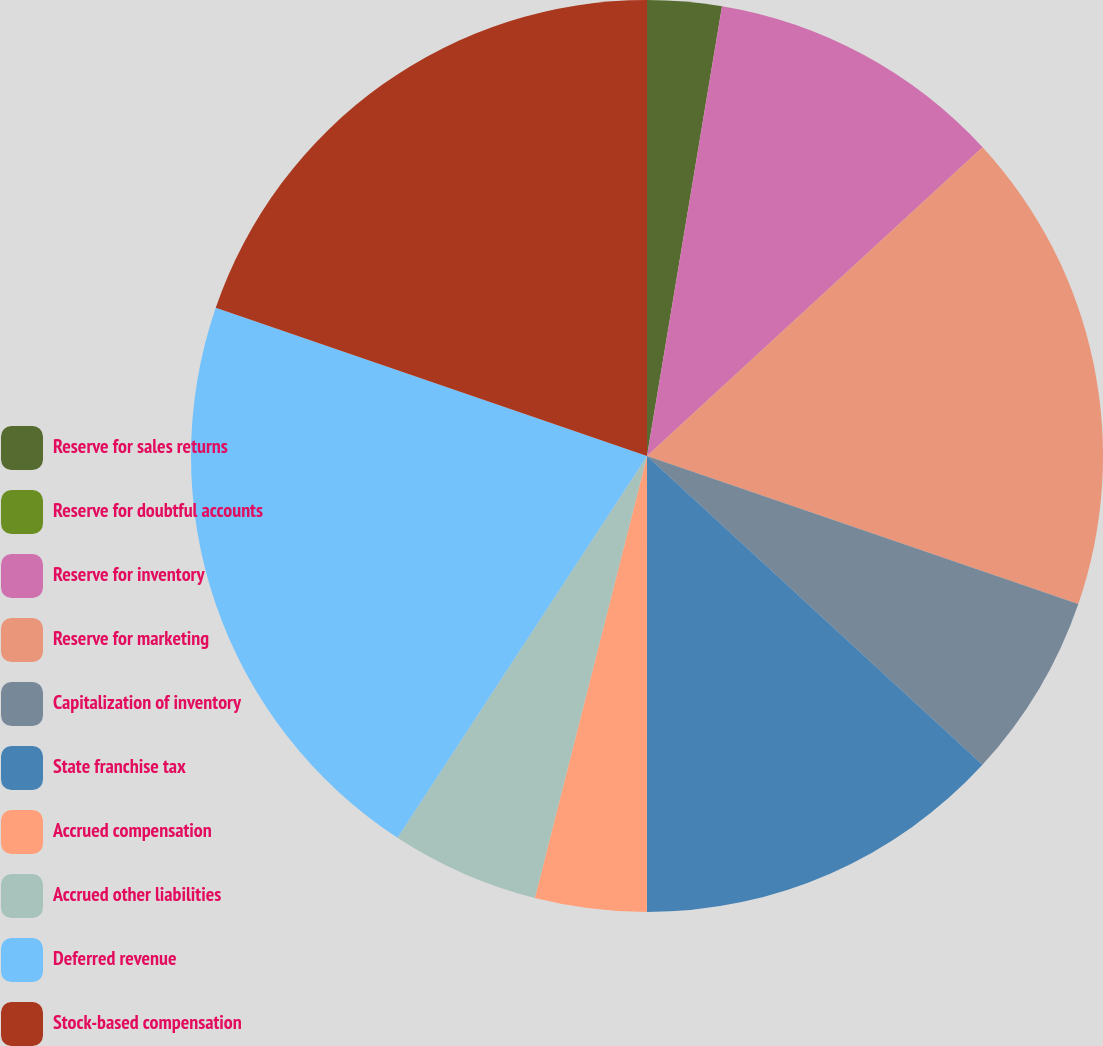<chart> <loc_0><loc_0><loc_500><loc_500><pie_chart><fcel>Reserve for sales returns<fcel>Reserve for doubtful accounts<fcel>Reserve for inventory<fcel>Reserve for marketing<fcel>Capitalization of inventory<fcel>State franchise tax<fcel>Accrued compensation<fcel>Accrued other liabilities<fcel>Deferred revenue<fcel>Stock-based compensation<nl><fcel>2.63%<fcel>0.0%<fcel>10.53%<fcel>17.1%<fcel>6.58%<fcel>13.16%<fcel>3.95%<fcel>5.26%<fcel>21.05%<fcel>19.73%<nl></chart> 